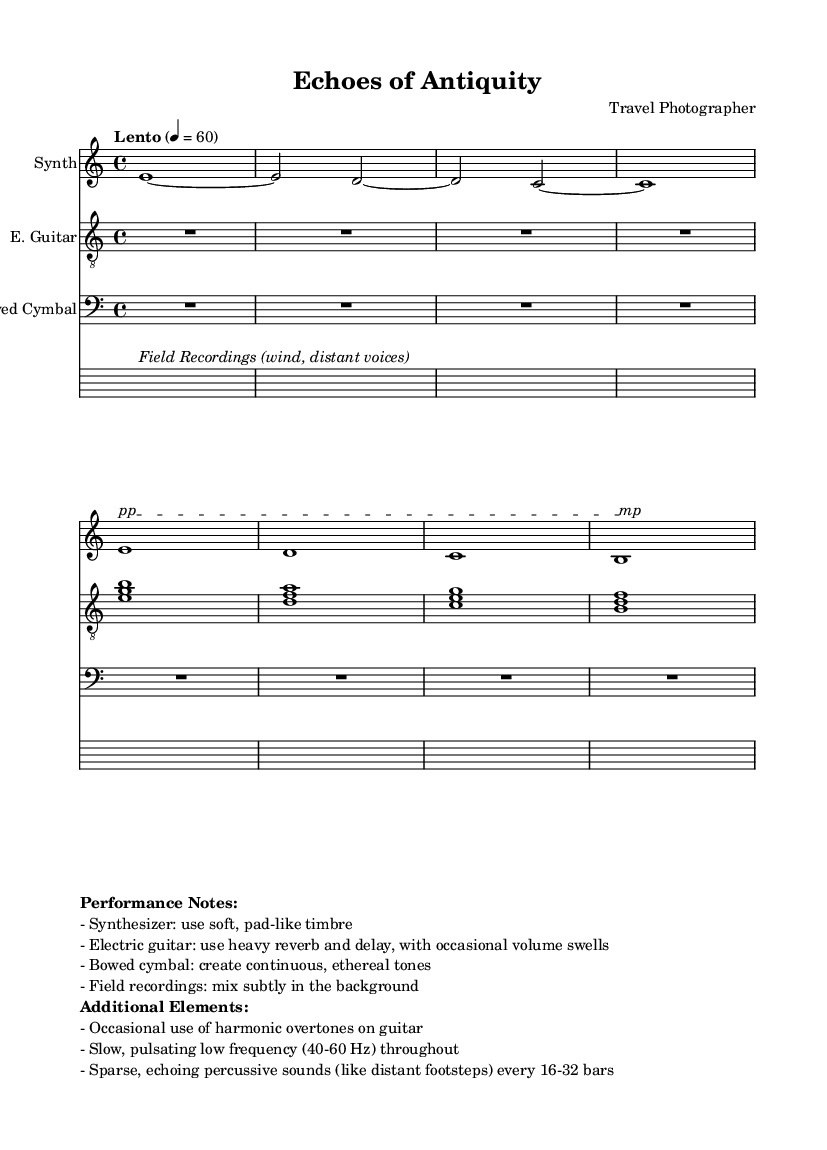What is the time signature of this music? The time signature is indicated at the beginning of the score as 4/4, which means there are four beats per measure and the quarter note receives one beat.
Answer: 4/4 What is the tempo marking for this piece? The tempo marking is specified as "Lento" with a metronome marking of 60 beats per minute, indicating a slow pace for the music.
Answer: Lento How many instruments are featured in this score? The score lists four distinct parts, each for different instruments: Synth, Electric Guitar, Bowed Cymbal, and Field Recordings.
Answer: Four What dynamic marking is indicated for the Synth part in the score? The marking for the Synth part shows a gradual dynamic change with "pp" (pianissimo) at the start of the text span and "mp" (mezzo-piano) at the end, suggesting a transition from a very soft to a moderately soft sound.
Answer: pp to mp Why is the tempo marked "Lento" especially appropriate for this piece? The term "Lento" implies a slow tempo, which suits the ambient and experimental nature of the music, evoking a sense of time passing and decay similar to ancient ruins. The slow pace allows for the gradual unfolding of sounds and textures typical of drone music.
Answer: Evoking time and decay What additional elements are suggested in the performance notes? The performance notes suggest using harmonic overtones on the guitar, a slow pulsating low frequency, and sparse percussive sounds throughout, enhancing the overall ambient texture.
Answer: Harmonic overtones, pulsating frequency, sparse sounds What kind of field recordings are incorporated in this composition? The score indicates that the field recordings include ambient sounds like wind and distant voices, which contribute to the immersive and decayed atmosphere of the piece.
Answer: Wind, distant voices 